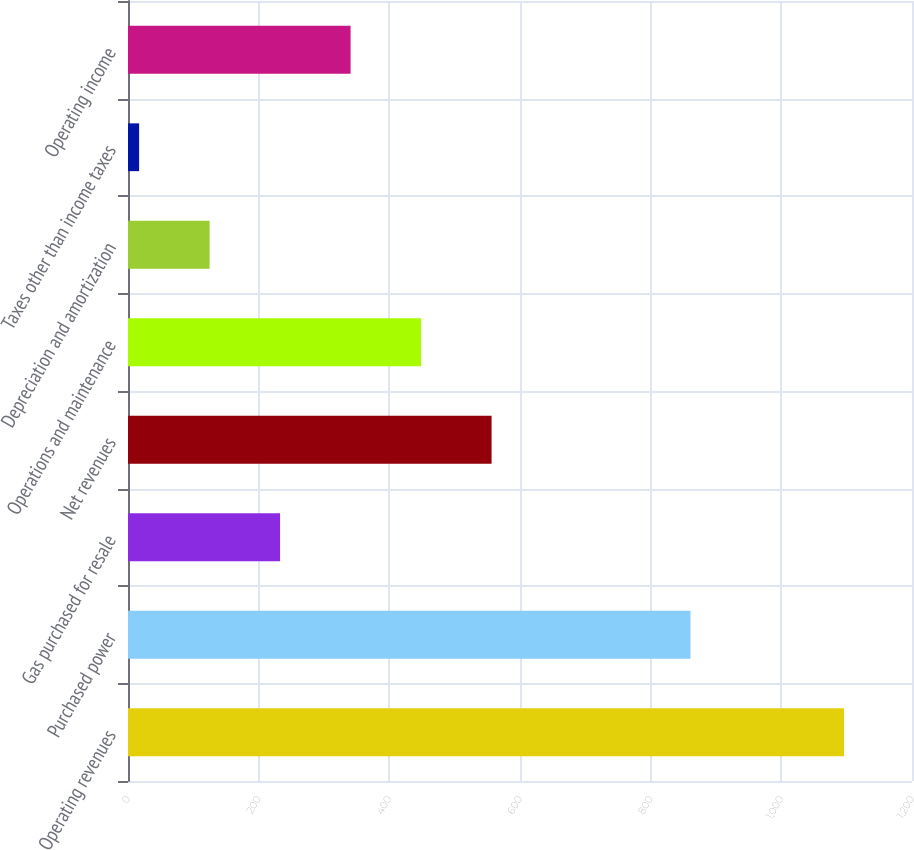Convert chart to OTSL. <chart><loc_0><loc_0><loc_500><loc_500><bar_chart><fcel>Operating revenues<fcel>Purchased power<fcel>Gas purchased for resale<fcel>Net revenues<fcel>Operations and maintenance<fcel>Depreciation and amortization<fcel>Taxes other than income taxes<fcel>Operating income<nl><fcel>1096<fcel>861<fcel>232.8<fcel>556.5<fcel>448.6<fcel>124.9<fcel>17<fcel>340.7<nl></chart> 